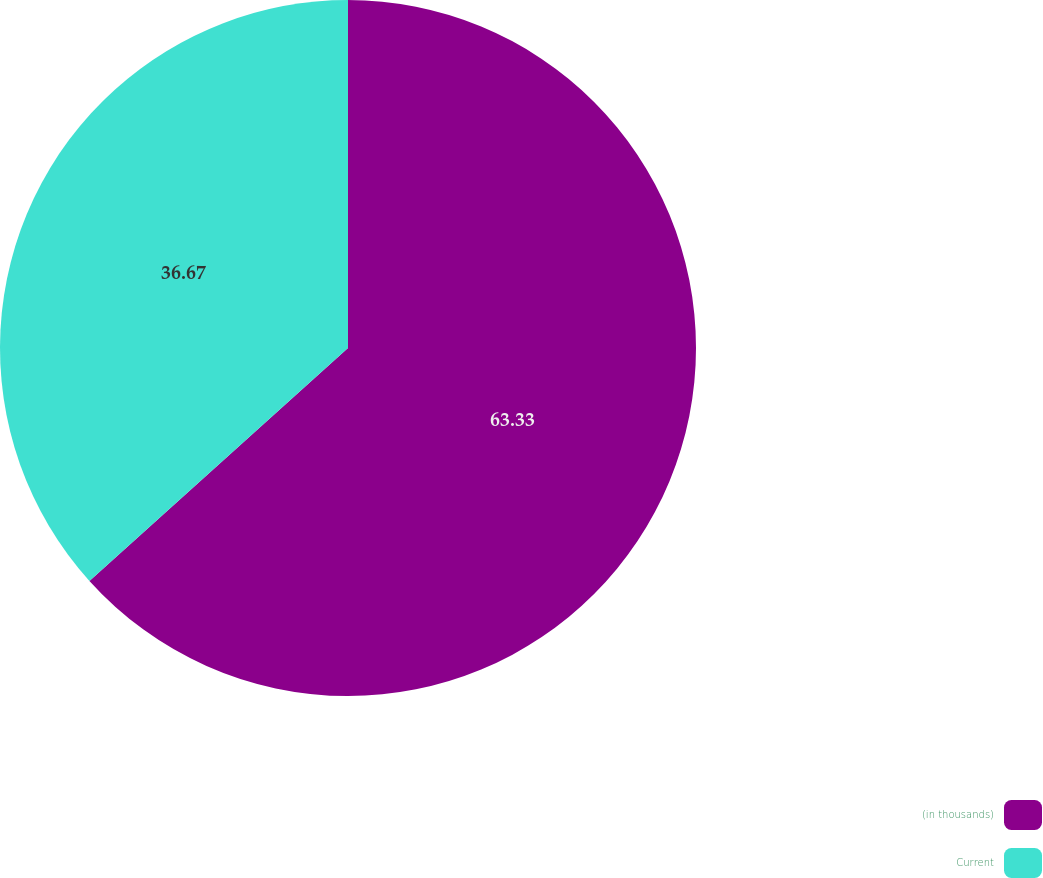Convert chart to OTSL. <chart><loc_0><loc_0><loc_500><loc_500><pie_chart><fcel>(in thousands)<fcel>Current<nl><fcel>63.33%<fcel>36.67%<nl></chart> 